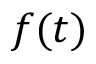<formula> <loc_0><loc_0><loc_500><loc_500>f ( t )</formula> 